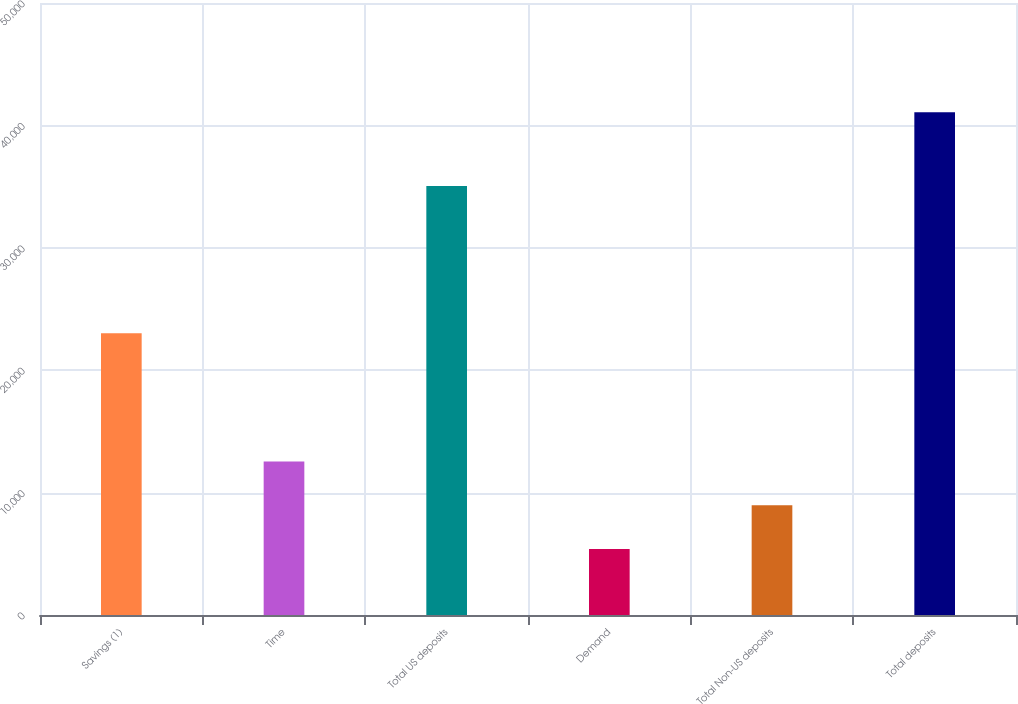<chart> <loc_0><loc_0><loc_500><loc_500><bar_chart><fcel>Savings (1)<fcel>Time<fcel>Total US deposits<fcel>Demand<fcel>Total Non-US deposits<fcel>Total deposits<nl><fcel>23024<fcel>12536.8<fcel>35043<fcel>5402<fcel>8969.4<fcel>41076<nl></chart> 